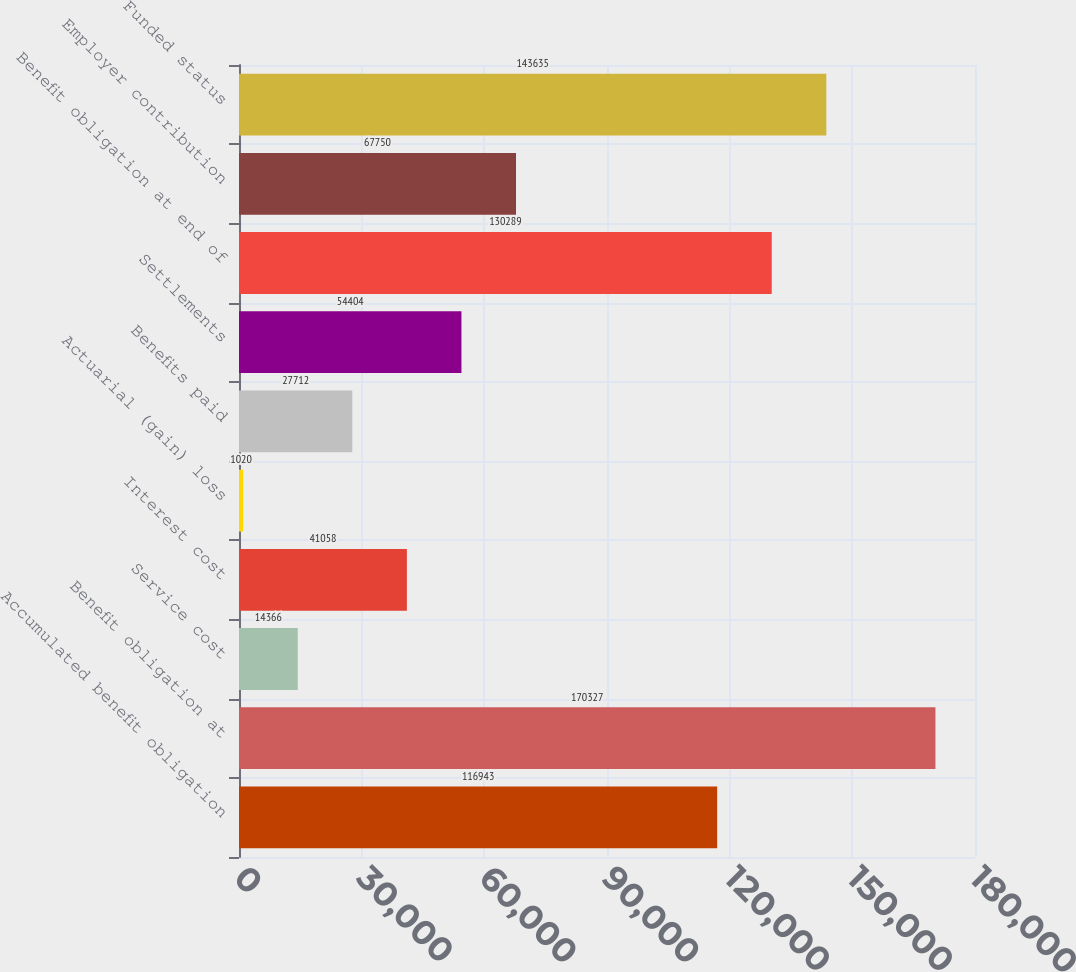Convert chart. <chart><loc_0><loc_0><loc_500><loc_500><bar_chart><fcel>Accumulated benefit obligation<fcel>Benefit obligation at<fcel>Service cost<fcel>Interest cost<fcel>Actuarial (gain) loss<fcel>Benefits paid<fcel>Settlements<fcel>Benefit obligation at end of<fcel>Employer contribution<fcel>Funded status<nl><fcel>116943<fcel>170327<fcel>14366<fcel>41058<fcel>1020<fcel>27712<fcel>54404<fcel>130289<fcel>67750<fcel>143635<nl></chart> 